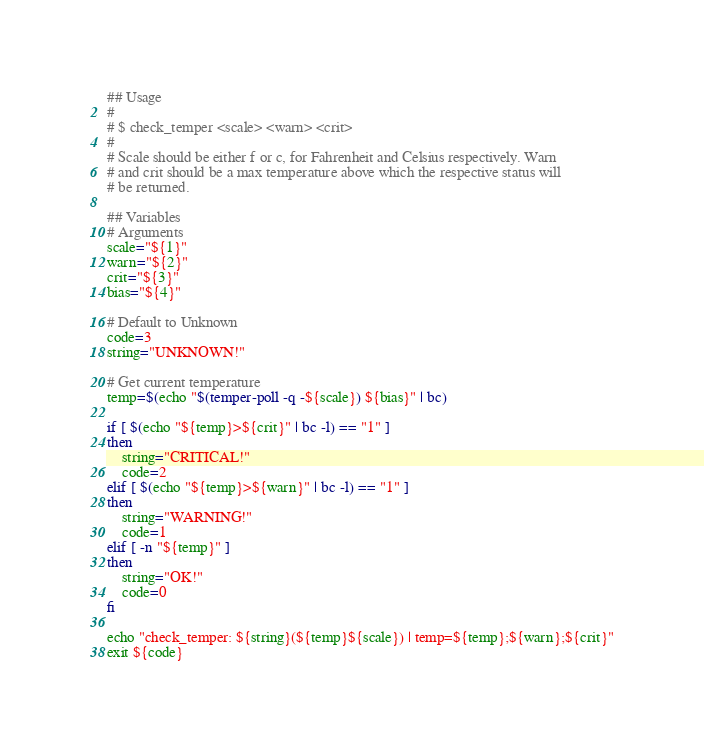<code> <loc_0><loc_0><loc_500><loc_500><_Bash_>## Usage
#
# $ check_temper <scale> <warn> <crit>
#
# Scale should be either f or c, for Fahrenheit and Celsius respectively. Warn
# and crit should be a max temperature above which the respective status will
# be returned.

## Variables
# Arguments
scale="${1}"
warn="${2}"
crit="${3}"
bias="${4}"

# Default to Unknown
code=3
string="UNKNOWN!"

# Get current temperature
temp=$(echo "$(temper-poll -q -${scale}) ${bias}" | bc)

if [ $(echo "${temp}>${crit}" | bc -l) == "1" ]
then
	string="CRITICAL!"
	code=2
elif [ $(echo "${temp}>${warn}" | bc -l) == "1" ]
then
	string="WARNING!"
	code=1
elif [ -n "${temp}" ]
then
	string="OK!"
	code=0
fi

echo "check_temper: ${string}(${temp}${scale}) | temp=${temp};${warn};${crit}"
exit ${code}

</code> 